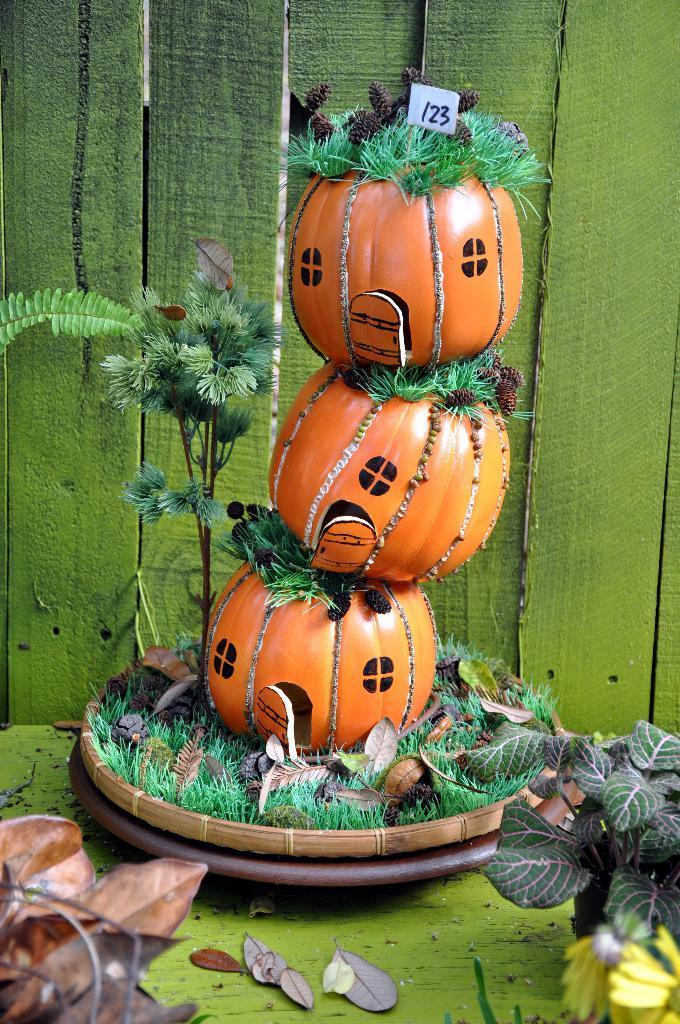Please provide a concise description of this image. In this image in the center there are three pumpkins in a plate, and also there are some plants and grass. On the right side and left side there are some plants and dry leaves, in the background there are wooden boards. 